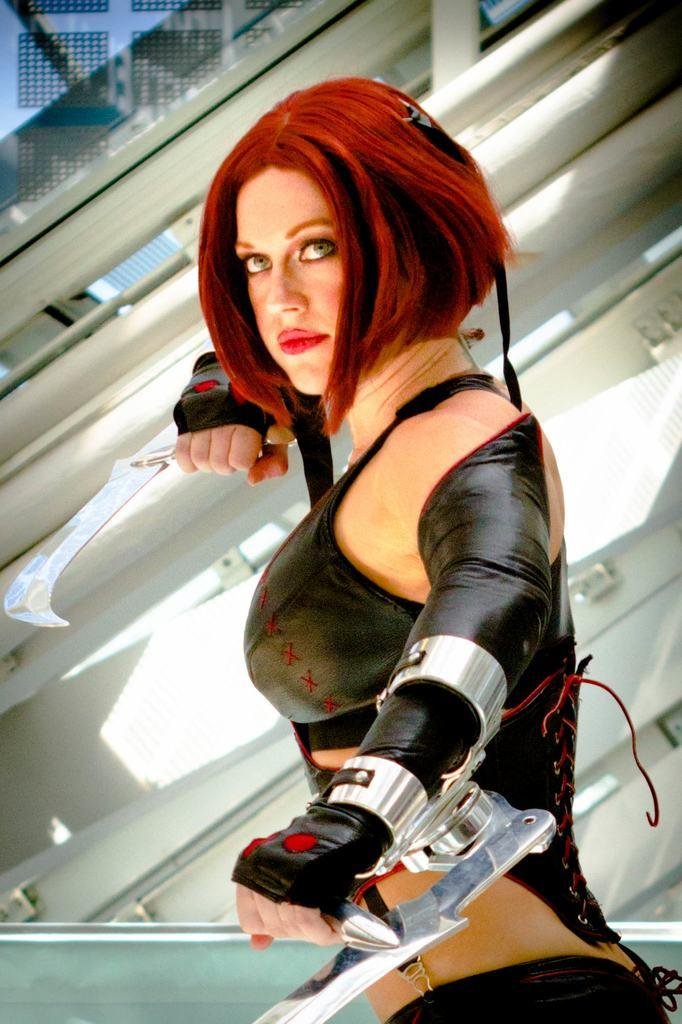Who is the main subject in the image? There is a woman in the image. Where is the woman positioned in the image? The woman is standing in the middle of the image. What is the woman holding in the image? The woman is holding knives. What can be seen behind the woman in the image? There is a wall behind the woman. What type of plants can be seen growing on the woman's tongue in the image? There is no mention of plants or a tongue in the image; the woman is holding knives and standing in front of a wall. 